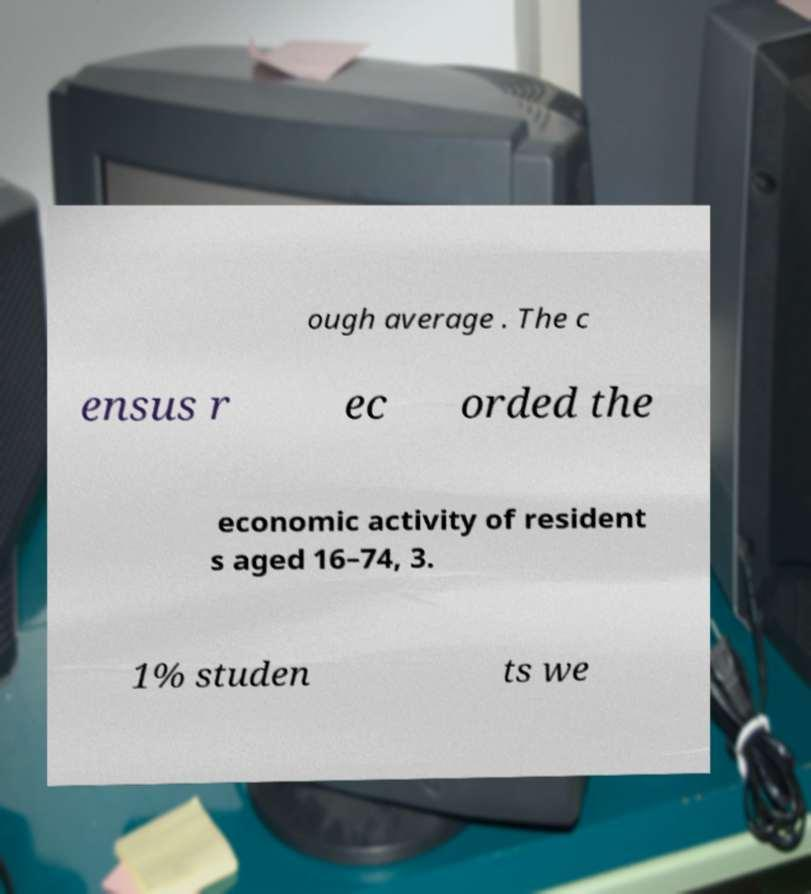Can you accurately transcribe the text from the provided image for me? ough average . The c ensus r ec orded the economic activity of resident s aged 16–74, 3. 1% studen ts we 